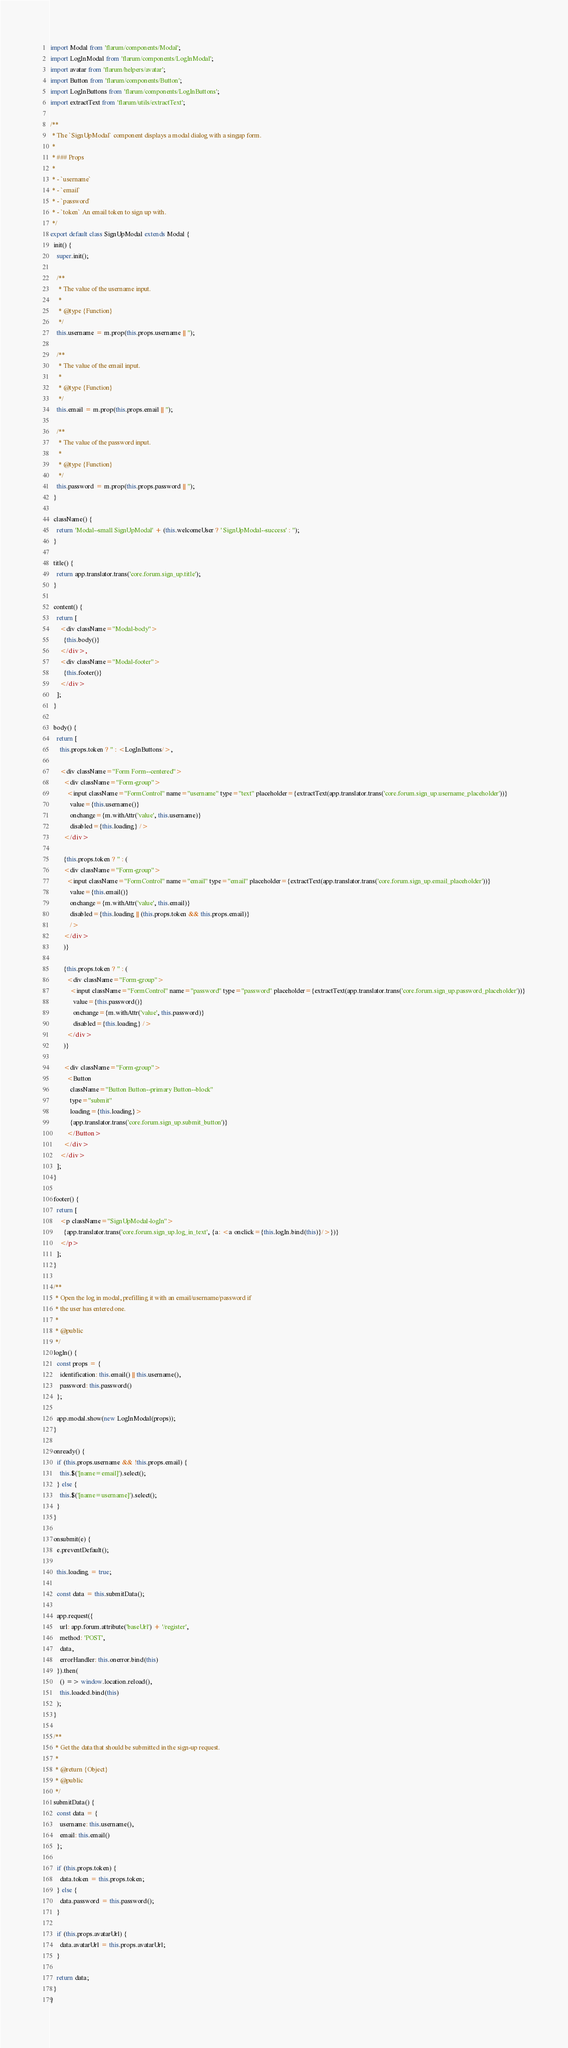Convert code to text. <code><loc_0><loc_0><loc_500><loc_500><_JavaScript_>import Modal from 'flarum/components/Modal';
import LogInModal from 'flarum/components/LogInModal';
import avatar from 'flarum/helpers/avatar';
import Button from 'flarum/components/Button';
import LogInButtons from 'flarum/components/LogInButtons';
import extractText from 'flarum/utils/extractText';

/**
 * The `SignUpModal` component displays a modal dialog with a singup form.
 *
 * ### Props
 *
 * - `username`
 * - `email`
 * - `password`
 * - `token` An email token to sign up with.
 */
export default class SignUpModal extends Modal {
  init() {
    super.init();

    /**
     * The value of the username input.
     *
     * @type {Function}
     */
    this.username = m.prop(this.props.username || '');

    /**
     * The value of the email input.
     *
     * @type {Function}
     */
    this.email = m.prop(this.props.email || '');

    /**
     * The value of the password input.
     *
     * @type {Function}
     */
    this.password = m.prop(this.props.password || '');
  }

  className() {
    return 'Modal--small SignUpModal' + (this.welcomeUser ? ' SignUpModal--success' : '');
  }

  title() {
    return app.translator.trans('core.forum.sign_up.title');
  }

  content() {
    return [
      <div className="Modal-body">
        {this.body()}
      </div>,
      <div className="Modal-footer">
        {this.footer()}
      </div>
    ];
  }

  body() {
    return [
      this.props.token ? '' : <LogInButtons/>,

      <div className="Form Form--centered">
        <div className="Form-group">
          <input className="FormControl" name="username" type="text" placeholder={extractText(app.translator.trans('core.forum.sign_up.username_placeholder'))}
            value={this.username()}
            onchange={m.withAttr('value', this.username)}
            disabled={this.loading} />
        </div>
        
        {this.props.token ? '' : (
        <div className="Form-group">
          <input className="FormControl" name="email" type="email" placeholder={extractText(app.translator.trans('core.forum.sign_up.email_placeholder'))}
            value={this.email()}
            onchange={m.withAttr('value', this.email)}
            disabled={this.loading || (this.props.token && this.props.email)} 
            />
        </div>
        )}

        {this.props.token ? '' : (
          <div className="Form-group">
            <input className="FormControl" name="password" type="password" placeholder={extractText(app.translator.trans('core.forum.sign_up.password_placeholder'))}
              value={this.password()}
              onchange={m.withAttr('value', this.password)}
              disabled={this.loading} />
          </div>
        )}

        <div className="Form-group">
          <Button
            className="Button Button--primary Button--block"
            type="submit"
            loading={this.loading}>
            {app.translator.trans('core.forum.sign_up.submit_button')}
          </Button>
        </div>
      </div>
    ];
  }

  footer() {
    return [
      <p className="SignUpModal-logIn">
        {app.translator.trans('core.forum.sign_up.log_in_text', {a: <a onclick={this.logIn.bind(this)}/>})}
      </p>
    ];
  }

  /**
   * Open the log in modal, prefilling it with an email/username/password if
   * the user has entered one.
   *
   * @public
   */
  logIn() {
    const props = {
      identification: this.email() || this.username(),
      password: this.password()
    };

    app.modal.show(new LogInModal(props));
  }

  onready() {
    if (this.props.username && !this.props.email) {
      this.$('[name=email]').select();
    } else {
      this.$('[name=username]').select();
    }
  }

  onsubmit(e) {
    e.preventDefault();

    this.loading = true;

    const data = this.submitData();

    app.request({
      url: app.forum.attribute('baseUrl') + '/register',
      method: 'POST',
      data,
      errorHandler: this.onerror.bind(this)
    }).then(
      () => window.location.reload(),
      this.loaded.bind(this)
    );
  }

  /**
   * Get the data that should be submitted in the sign-up request.
   *
   * @return {Object}
   * @public
   */
  submitData() {
    const data = {
      username: this.username(),
      email: this.email()
    };

    if (this.props.token) {
      data.token = this.props.token;
    } else {
      data.password = this.password();
    }

    if (this.props.avatarUrl) {
      data.avatarUrl = this.props.avatarUrl;
    }

    return data;
  }
}
</code> 